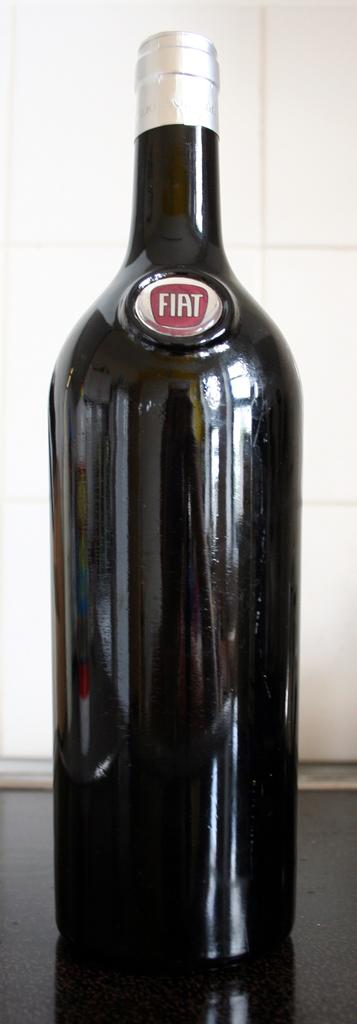Provide a one-sentence caption for the provided image. A dark colored wine bottle with a silver seal with the name Fiat on the front of the bottle. 